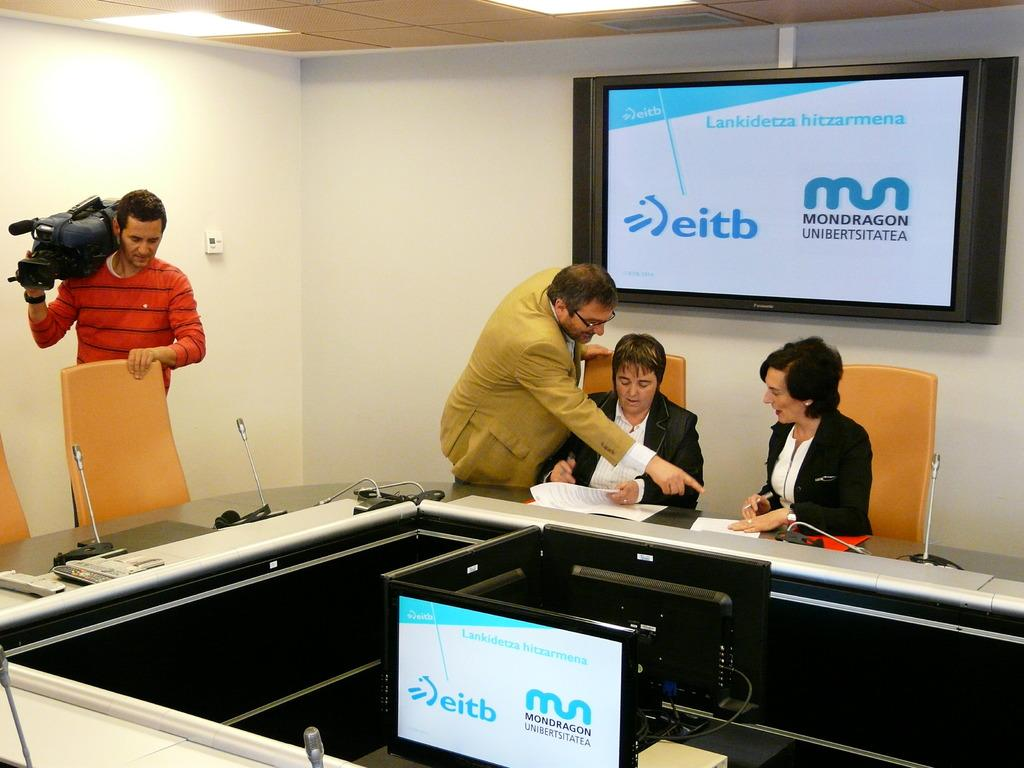<image>
Relay a brief, clear account of the picture shown. Two men and two women are working in meeting room for Mondragon. 